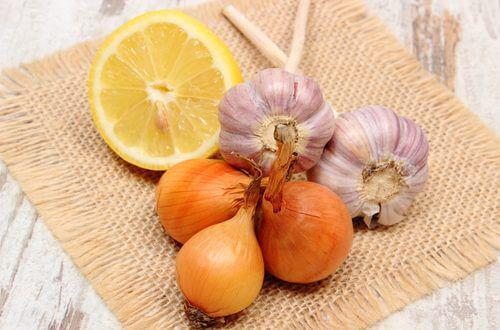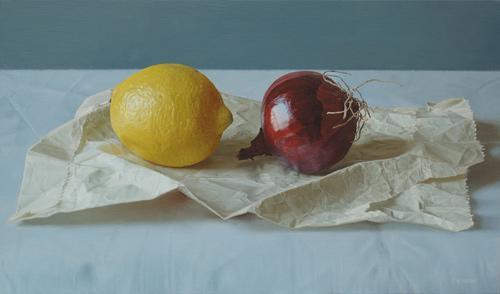The first image is the image on the left, the second image is the image on the right. Given the left and right images, does the statement "In one of the images there is a whole lemon next to a whole onion." hold true? Answer yes or no. Yes. The first image is the image on the left, the second image is the image on the right. Considering the images on both sides, is "An image includes a whole onion and a half lemon, but not a whole lemon or a half onion." valid? Answer yes or no. Yes. 